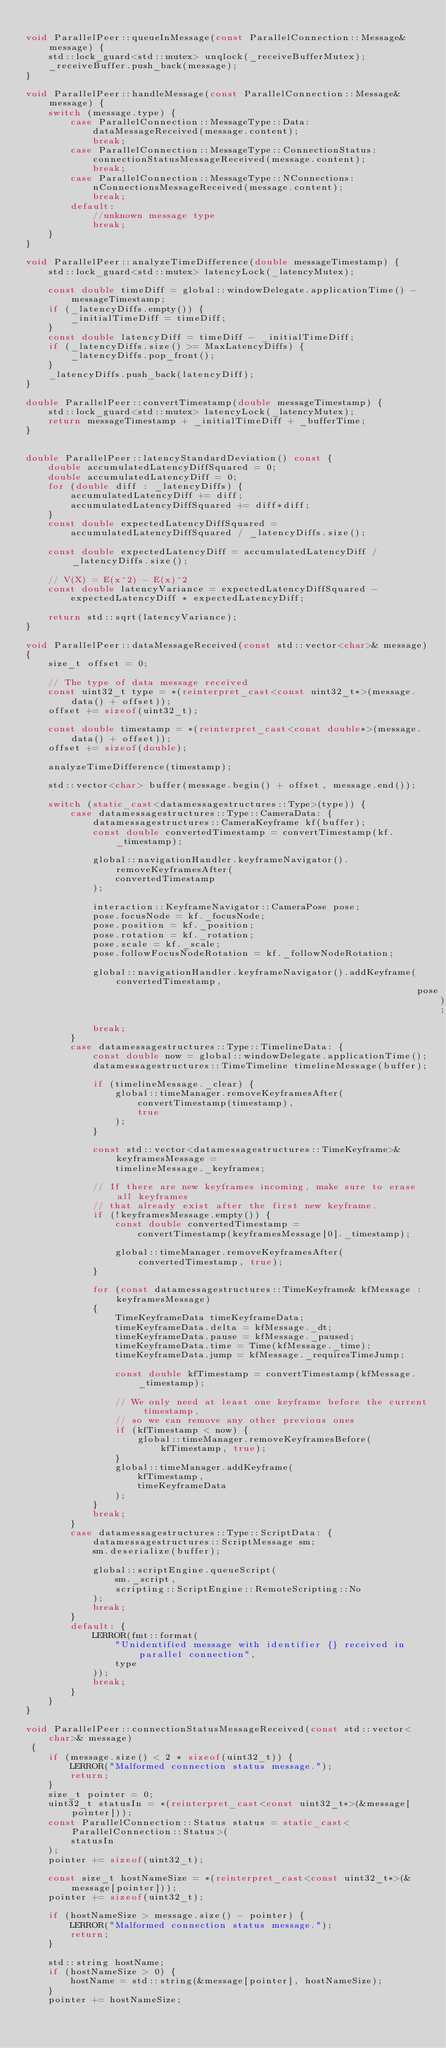<code> <loc_0><loc_0><loc_500><loc_500><_C++_>
void ParallelPeer::queueInMessage(const ParallelConnection::Message& message) {
    std::lock_guard<std::mutex> unqlock(_receiveBufferMutex);
    _receiveBuffer.push_back(message);
}

void ParallelPeer::handleMessage(const ParallelConnection::Message& message) {
    switch (message.type) {
        case ParallelConnection::MessageType::Data:
            dataMessageReceived(message.content);
            break;
        case ParallelConnection::MessageType::ConnectionStatus:
            connectionStatusMessageReceived(message.content);
            break;
        case ParallelConnection::MessageType::NConnections:
            nConnectionsMessageReceived(message.content);
            break;
        default:
            //unknown message type
            break;
    }
}

void ParallelPeer::analyzeTimeDifference(double messageTimestamp) {
    std::lock_guard<std::mutex> latencyLock(_latencyMutex);

    const double timeDiff = global::windowDelegate.applicationTime() - messageTimestamp;
    if (_latencyDiffs.empty()) {
        _initialTimeDiff = timeDiff;
    }
    const double latencyDiff = timeDiff - _initialTimeDiff;
    if (_latencyDiffs.size() >= MaxLatencyDiffs) {
        _latencyDiffs.pop_front();
    }
    _latencyDiffs.push_back(latencyDiff);
}

double ParallelPeer::convertTimestamp(double messageTimestamp) {
    std::lock_guard<std::mutex> latencyLock(_latencyMutex);
    return messageTimestamp + _initialTimeDiff + _bufferTime;
}


double ParallelPeer::latencyStandardDeviation() const {
    double accumulatedLatencyDiffSquared = 0;
    double accumulatedLatencyDiff = 0;
    for (double diff : _latencyDiffs) {
        accumulatedLatencyDiff += diff;
        accumulatedLatencyDiffSquared += diff*diff;
    }
    const double expectedLatencyDiffSquared =
        accumulatedLatencyDiffSquared / _latencyDiffs.size();

    const double expectedLatencyDiff = accumulatedLatencyDiff / _latencyDiffs.size();

    // V(X) = E(x^2) - E(x)^2
    const double latencyVariance = expectedLatencyDiffSquared -
        expectedLatencyDiff * expectedLatencyDiff;

    return std::sqrt(latencyVariance);
}

void ParallelPeer::dataMessageReceived(const std::vector<char>& message)
{
    size_t offset = 0;

    // The type of data message received
    const uint32_t type = *(reinterpret_cast<const uint32_t*>(message.data() + offset));
    offset += sizeof(uint32_t);

    const double timestamp = *(reinterpret_cast<const double*>(message.data() + offset));
    offset += sizeof(double);

    analyzeTimeDifference(timestamp);

    std::vector<char> buffer(message.begin() + offset, message.end());

    switch (static_cast<datamessagestructures::Type>(type)) {
        case datamessagestructures::Type::CameraData: {
            datamessagestructures::CameraKeyframe kf(buffer);
            const double convertedTimestamp = convertTimestamp(kf._timestamp);

            global::navigationHandler.keyframeNavigator().removeKeyframesAfter(
                convertedTimestamp
            );

            interaction::KeyframeNavigator::CameraPose pose;
            pose.focusNode = kf._focusNode;
            pose.position = kf._position;
            pose.rotation = kf._rotation;
            pose.scale = kf._scale;
            pose.followFocusNodeRotation = kf._followNodeRotation;

            global::navigationHandler.keyframeNavigator().addKeyframe(convertedTimestamp,
                                                                      pose);
            break;
        }
        case datamessagestructures::Type::TimelineData: {
            const double now = global::windowDelegate.applicationTime();
            datamessagestructures::TimeTimeline timelineMessage(buffer);

            if (timelineMessage._clear) {
                global::timeManager.removeKeyframesAfter(
                    convertTimestamp(timestamp),
                    true
                );
            }

            const std::vector<datamessagestructures::TimeKeyframe>& keyframesMessage =
                timelineMessage._keyframes;

            // If there are new keyframes incoming, make sure to erase all keyframes
            // that already exist after the first new keyframe.
            if (!keyframesMessage.empty()) {
                const double convertedTimestamp =
                    convertTimestamp(keyframesMessage[0]._timestamp);

                global::timeManager.removeKeyframesAfter(convertedTimestamp, true);
            }

            for (const datamessagestructures::TimeKeyframe& kfMessage : keyframesMessage)
            {
                TimeKeyframeData timeKeyframeData;
                timeKeyframeData.delta = kfMessage._dt;
                timeKeyframeData.pause = kfMessage._paused;
                timeKeyframeData.time = Time(kfMessage._time);
                timeKeyframeData.jump = kfMessage._requiresTimeJump;

                const double kfTimestamp = convertTimestamp(kfMessage._timestamp);

                // We only need at least one keyframe before the current timestamp,
                // so we can remove any other previous ones
                if (kfTimestamp < now) {
                    global::timeManager.removeKeyframesBefore(kfTimestamp, true);
                }
                global::timeManager.addKeyframe(
                    kfTimestamp,
                    timeKeyframeData
                );
            }
            break;
        }
        case datamessagestructures::Type::ScriptData: {
            datamessagestructures::ScriptMessage sm;
            sm.deserialize(buffer);

            global::scriptEngine.queueScript(
                sm._script,
                scripting::ScriptEngine::RemoteScripting::No
            );
            break;
        }
        default: {
            LERROR(fmt::format(
                "Unidentified message with identifier {} received in parallel connection",
                type
            ));
            break;
        }
    }
}

void ParallelPeer::connectionStatusMessageReceived(const std::vector<char>& message)
 {
    if (message.size() < 2 * sizeof(uint32_t)) {
        LERROR("Malformed connection status message.");
        return;
    }
    size_t pointer = 0;
    uint32_t statusIn = *(reinterpret_cast<const uint32_t*>(&message[pointer]));
    const ParallelConnection::Status status = static_cast<ParallelConnection::Status>(
        statusIn
    );
    pointer += sizeof(uint32_t);

    const size_t hostNameSize = *(reinterpret_cast<const uint32_t*>(&message[pointer]));
    pointer += sizeof(uint32_t);

    if (hostNameSize > message.size() - pointer) {
        LERROR("Malformed connection status message.");
        return;
    }

    std::string hostName;
    if (hostNameSize > 0) {
        hostName = std::string(&message[pointer], hostNameSize);
    }
    pointer += hostNameSize;
</code> 